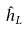Convert formula to latex. <formula><loc_0><loc_0><loc_500><loc_500>\hat { h } _ { L }</formula> 